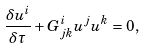<formula> <loc_0><loc_0><loc_500><loc_500>\frac { \delta u ^ { i } } { \delta \tau } + G ^ { i } _ { j k } u ^ { j } u ^ { k } = 0 ,</formula> 